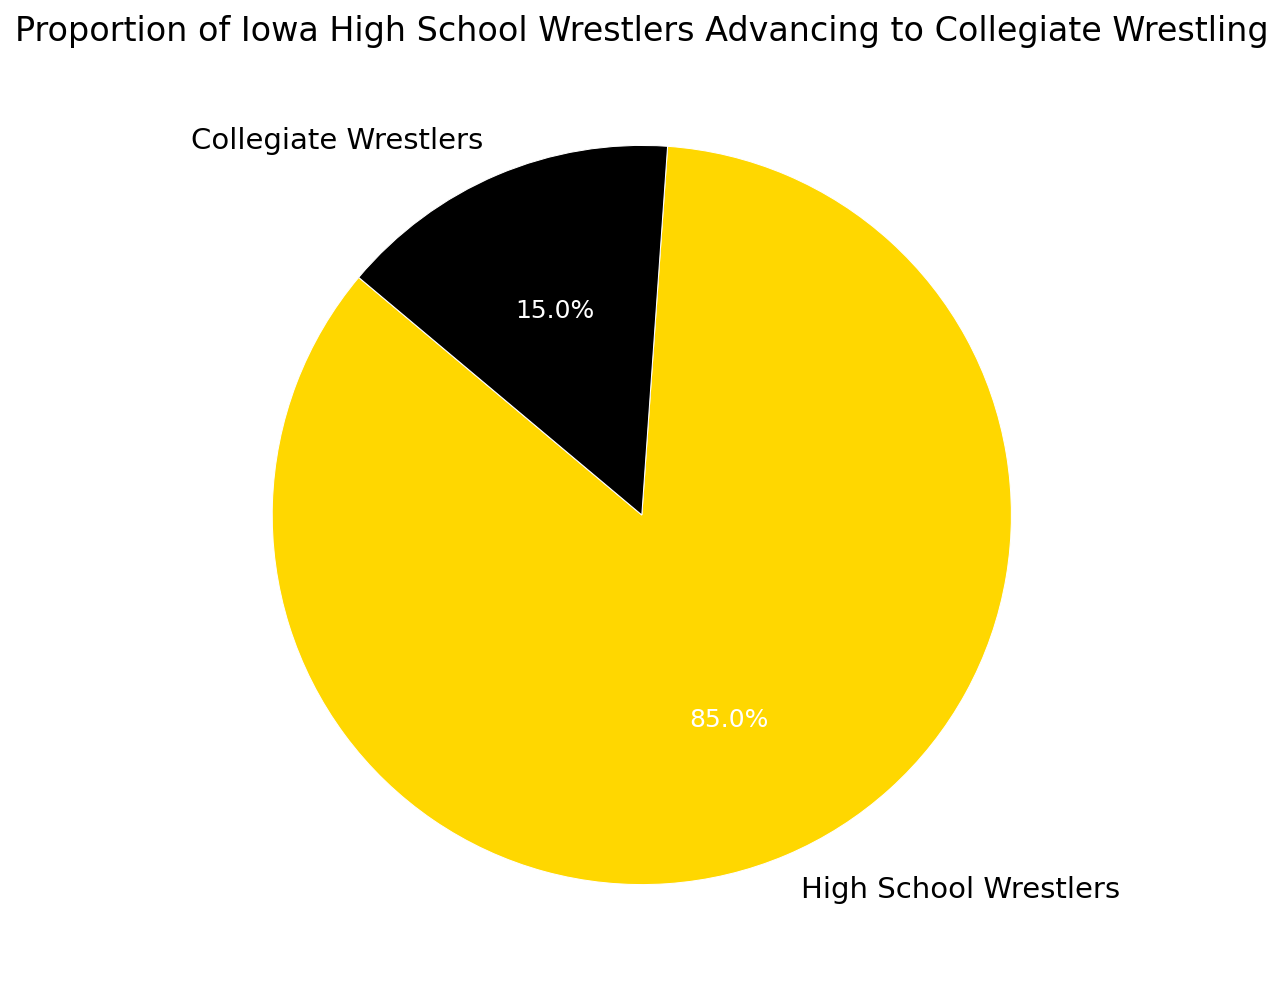what proportion of Iowa high school wrestlers advanced to collegiate wrestling? Look at the pie chart and locate the segment labeled "Collegiate Wrestlers." The percentage displayed in this segment is the proportion of high school wrestlers who advanced to collegiate wrestling.
Answer: 15% Which group is larger, high school wrestlers or collegiate wrestlers? Examine the pie chart and compare the sizes of the segments labeled "High School Wrestlers" and "Collegiate Wrestlers." The "High School Wrestlers" segment is larger.
Answer: High School Wrestlers What color represents high school wrestlers in the pie chart? Identify the color of the segment labeled "High School Wrestlers" in the chart.
Answer: Gold What percentage of Iowa high school wrestlers did not advance to collegiate wrestling? To find out what percentage did not advance, subtract the proportion of collegiate wrestlers from the total 100%. \(100\% - 15\% = 85\%\)
Answer: 85% How many times larger is the proportion of high school wrestlers compared to collegiate wrestlers? Divide the proportion of high school wrestlers by the proportion of collegiate wrestlers. \(85\% \div 15\% = 5.67\)
Answer: About 5.67 times Compare the proportions of the two categories in the chart. The chart shows that high school wrestlers make up 85% while collegiate wrestlers make up 15%.
Answer: High School Wrestlers have a higher proportion What is the combined percentage of wrestlers represented in the chart? Add the percentage of high school wrestlers and collegiate wrestlers together: \(85\% + 15\% = 100\%\)
Answer: 100% If you were to represent the proportions as fractions, how would you express the proportion of high school wrestlers? Convert the percentage to a fraction by dividing by 100: \(85\% = \frac{85}{100} = \frac{17}{20}\)
Answer: 17/20 By how much does the proportion of high school wrestlers exceed that of collegiate wrestlers? Subtract the percentage of collegiate wrestlers from the percentage of high school wrestlers: \(85\% - 15\% = 70\%\)
Answer: 70% What is the title of the chart, and what does it convey about the data? Read the title at the top of the chart: "Proportion of Iowa High School Wrestlers Advancing to Collegiate Wrestling." It conveys the proportion of high school wrestlers who go on to wrestle in college versus those who do not.
Answer: Proportion of Iowa High School Wrestlers Advancing to Collegiate Wrestling 